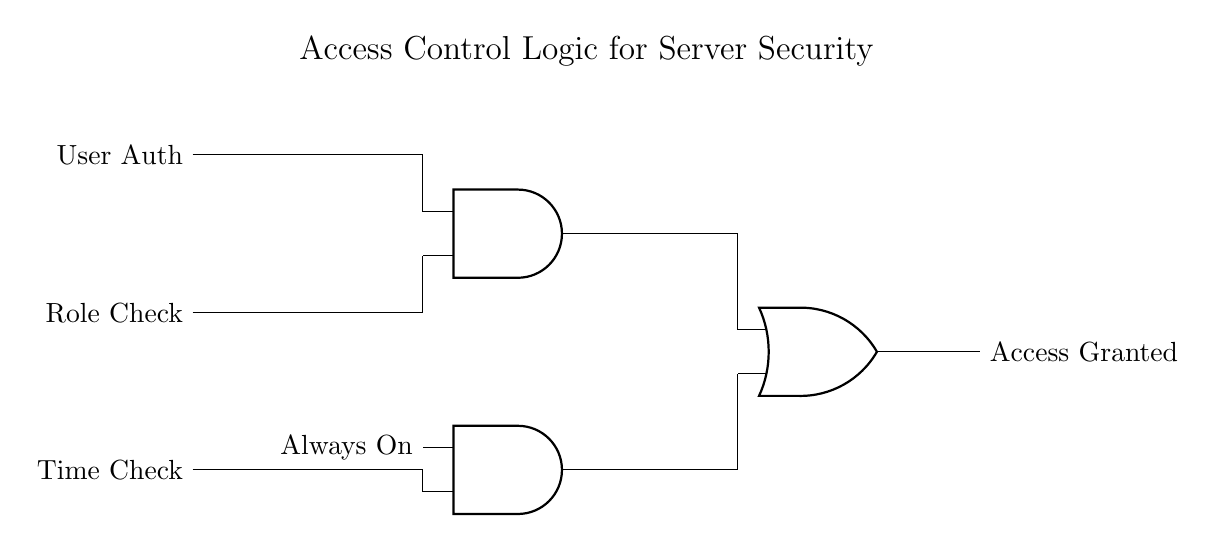What are the inputs to this circuit? The circuit has three inputs: User Authentication, Role Check, and Time Check. These inputs are identified in the diagram as they are connected to the respective logic gates.
Answer: User Authentication, Role Check, Time Check What type of gate combines User Auth and Role Check? The circuit uses an AND gate to combine the User Auth and Role Check inputs. The AND gate is specifically designed to output a high signal only when both input conditions are met.
Answer: AND gate What is the output when both AND gate conditions are satisfied? The output from the OR gate, when both AND gate conditions are satisfied, will be "Access Granted." This is the final output that results when all necessary conditions for access are met.
Answer: Access Granted How many AND gates are present in the circuit? There are two AND gates in the circuit, one for combining User Auth and Role Check, and the other for the Time Check input. This setup allows multiple input conditions to be evaluated.
Answer: Two What is the role of the 'Always On' input in the circuit? The 'Always On' input serves as a constant signal to the AND gate that combines it with the Time Check. This means that the Time Check condition can alone determine whether access is granted when combined with it.
Answer: Constant signal What is the purpose of the OR gate in this circuit? The OR gate is used to determine the final access decision. It accepts inputs from both AND gates and produces a high output if at least one of the AND gates provides a high signal, signaling access grant.
Answer: Final access decision 